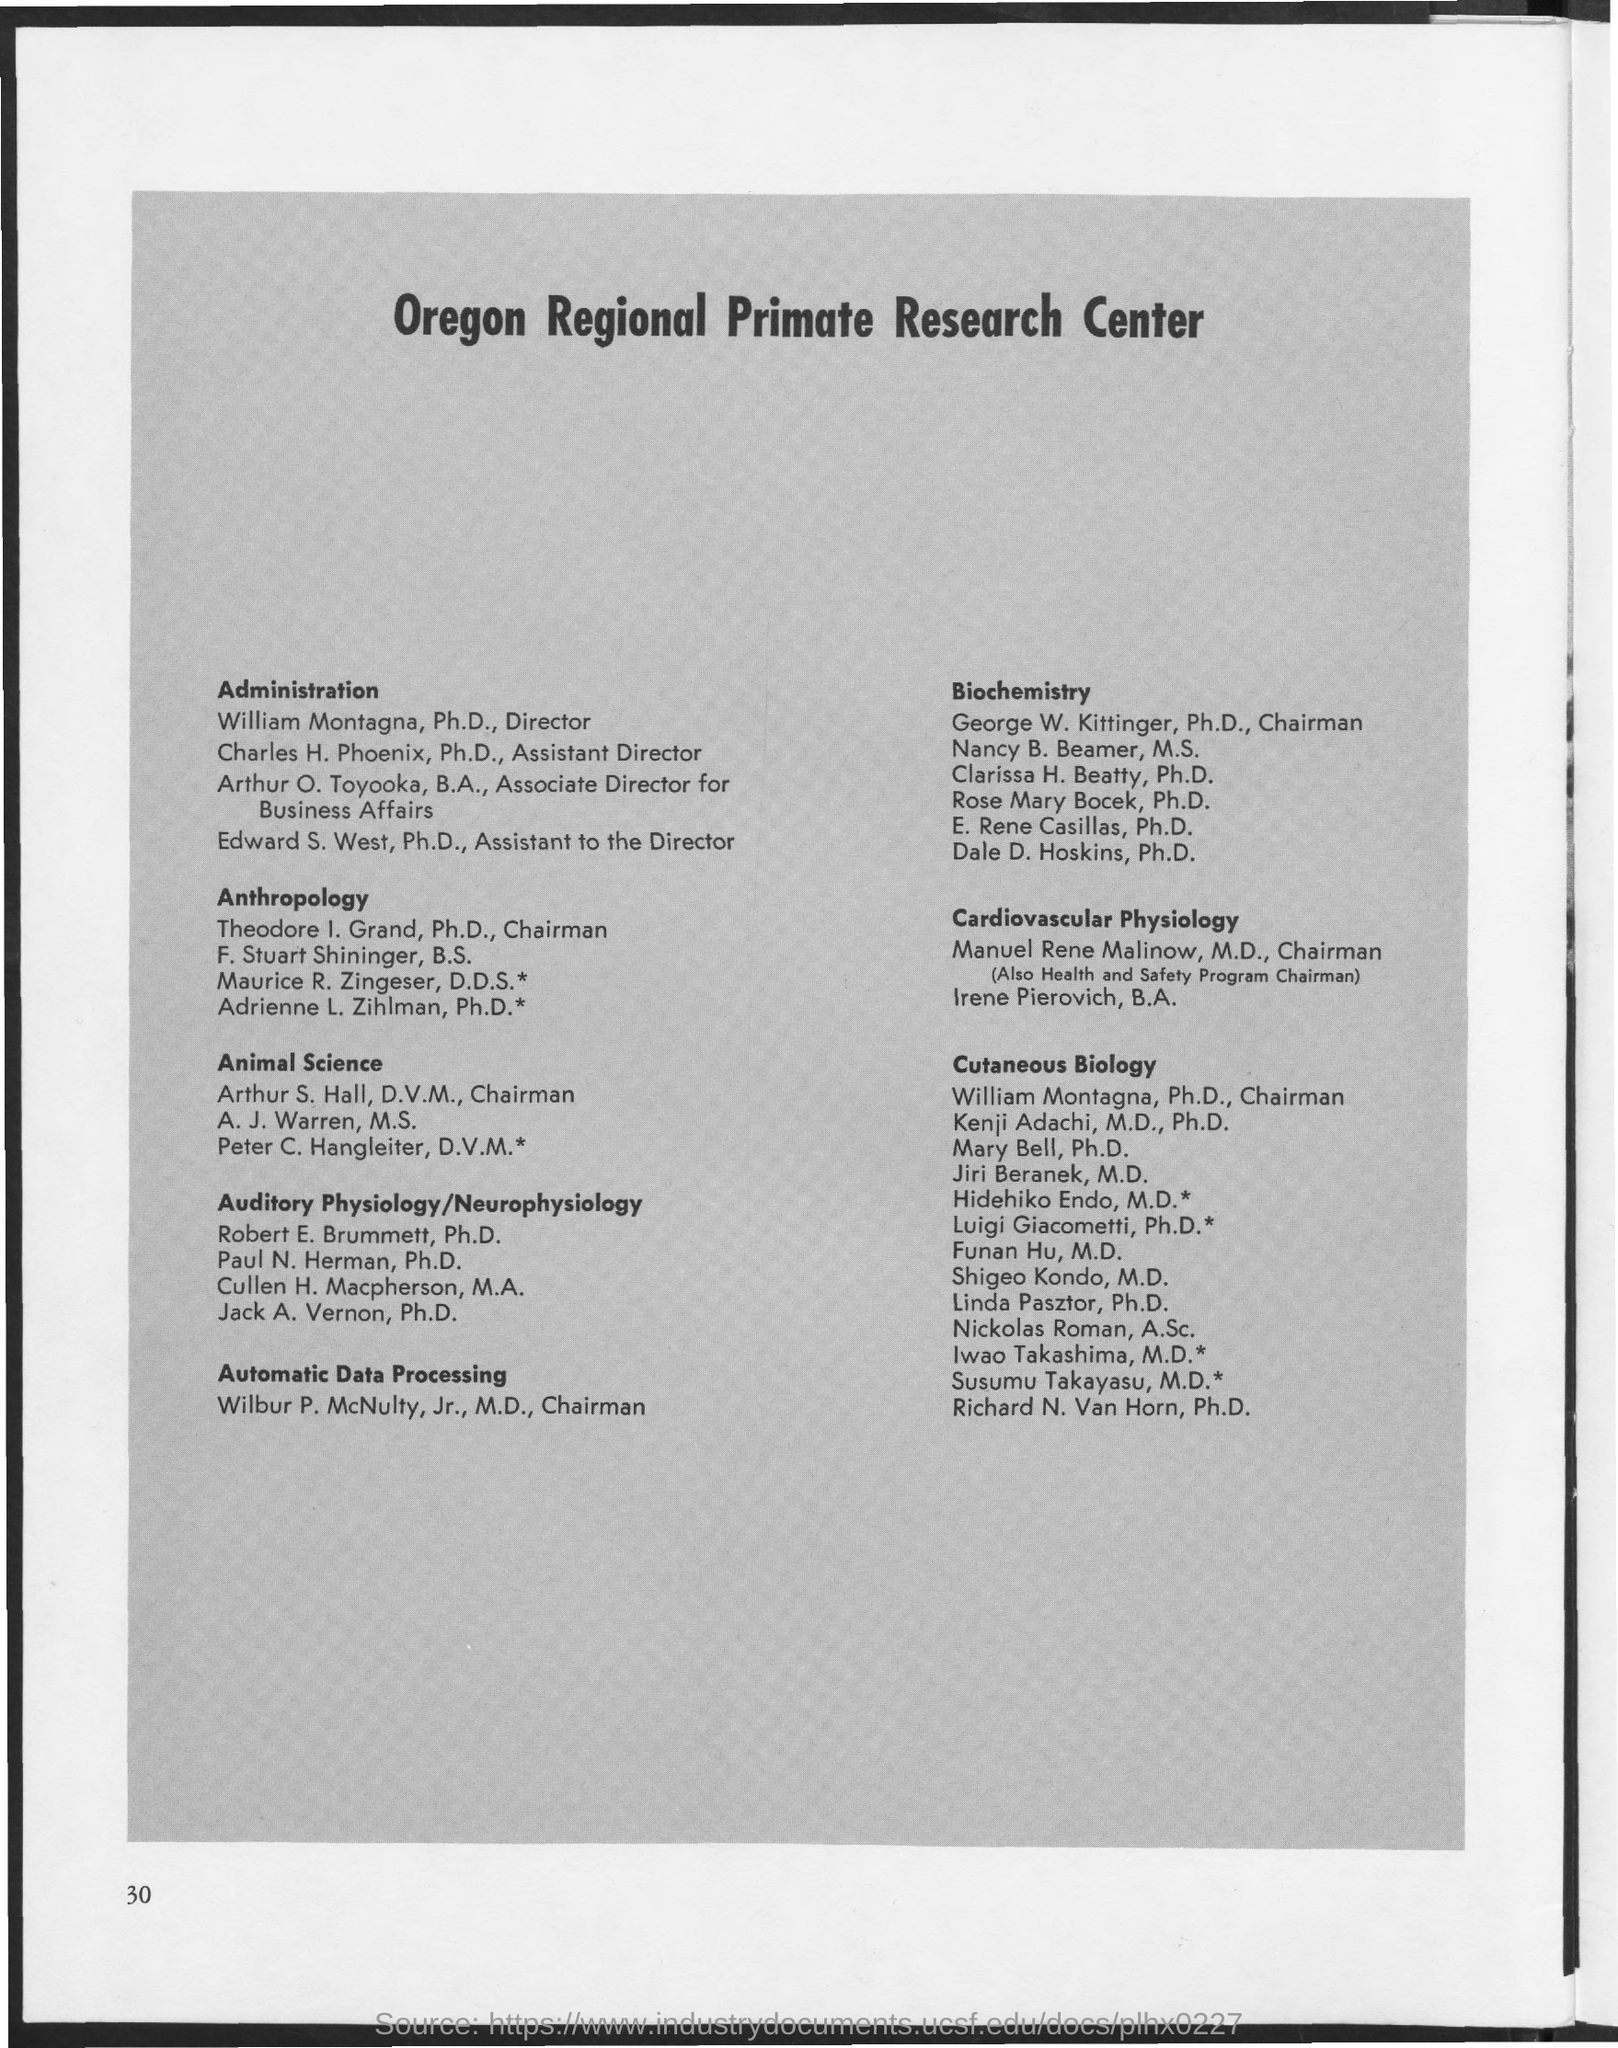Identify some key points in this picture. The page number is 30. 